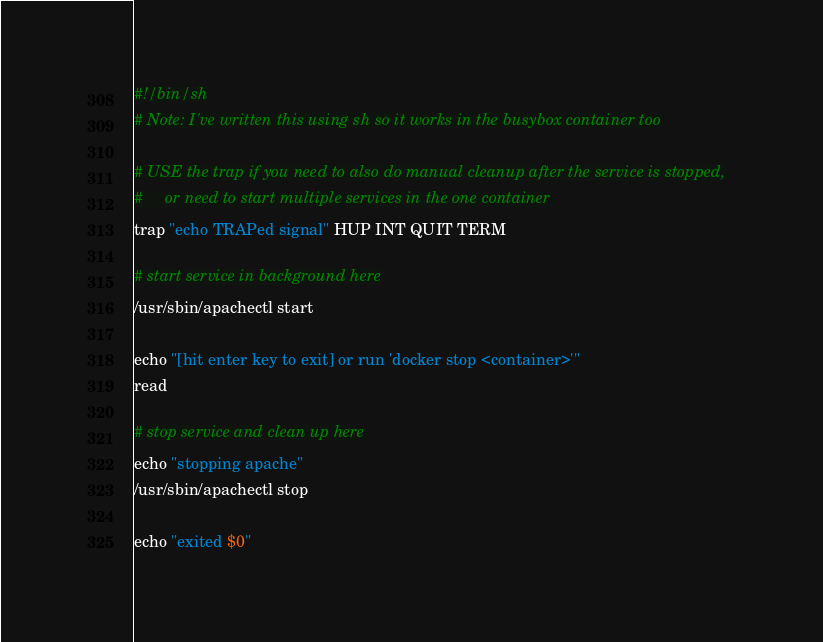Convert code to text. <code><loc_0><loc_0><loc_500><loc_500><_Bash_>#!/bin/sh
# Note: I've written this using sh so it works in the busybox container too

# USE the trap if you need to also do manual cleanup after the service is stopped,
#     or need to start multiple services in the one container
trap "echo TRAPed signal" HUP INT QUIT TERM

# start service in background here
/usr/sbin/apachectl start

echo "[hit enter key to exit] or run 'docker stop <container>'"
read

# stop service and clean up here
echo "stopping apache"
/usr/sbin/apachectl stop

echo "exited $0"</code> 